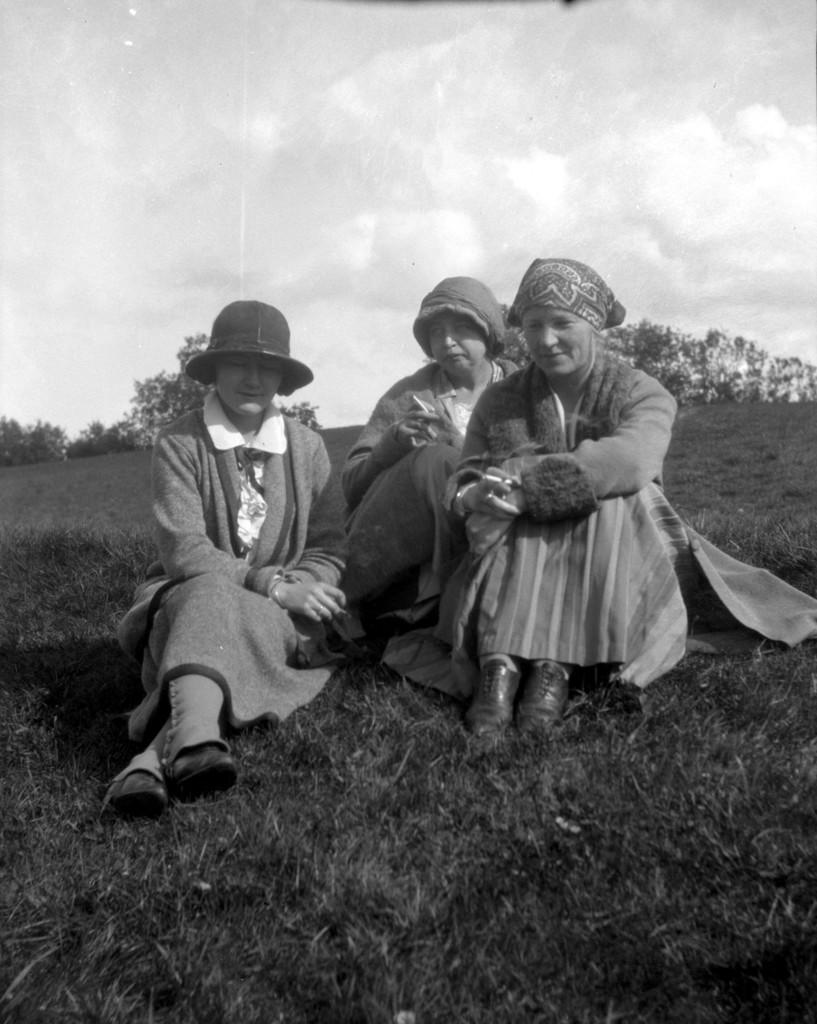How many women are in the image? There are three women in the image. What are the women wearing on their heads? The women are wearing hats. Where are the women sitting? The women are sitting on the grass. What can be seen in the background of the image? The area around them is surrounded by trees. What type of fork can be seen in the image? There is no fork present in the image. What is the women using to measure their height in the image? There is no scale present in the image, and the women's height is not being measured. 